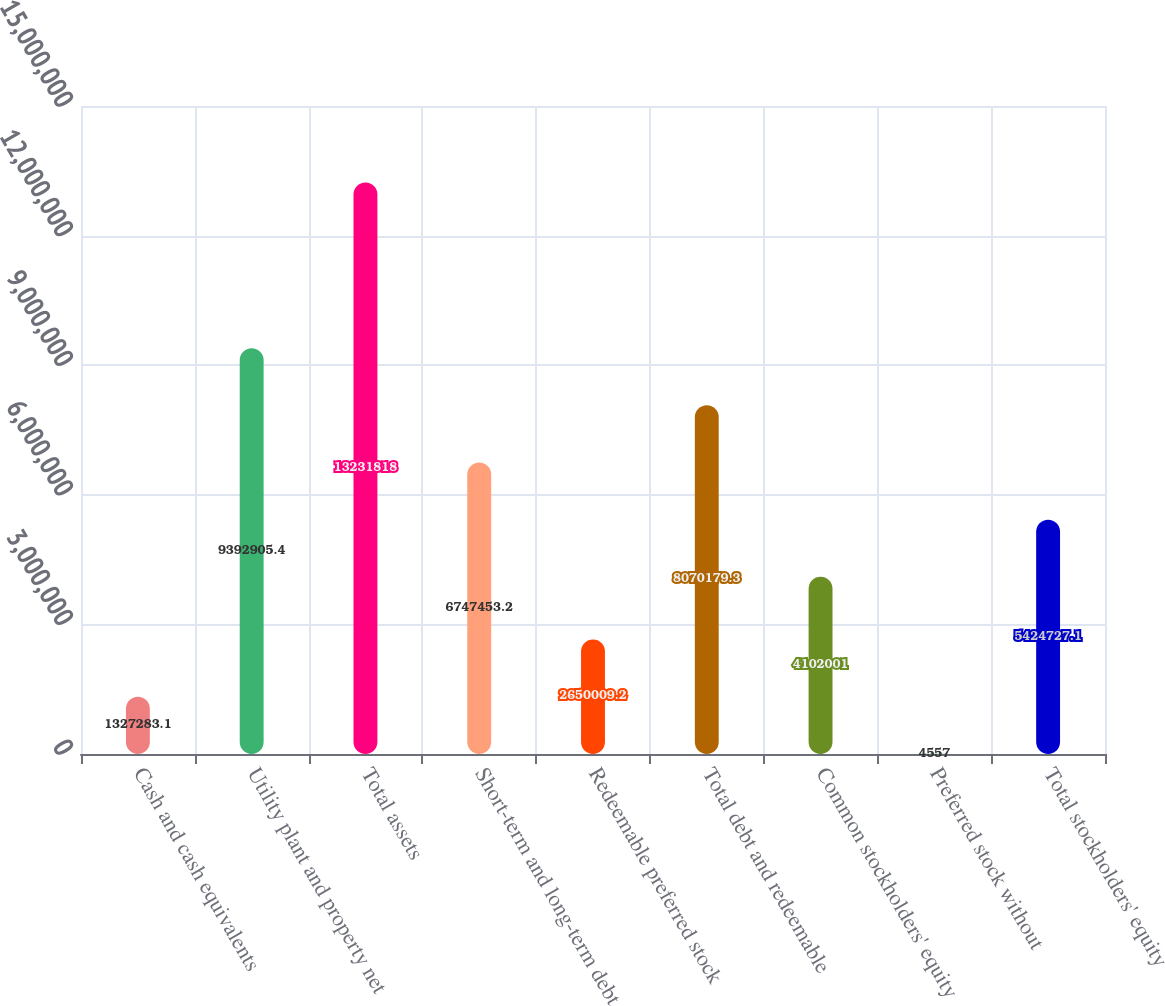<chart> <loc_0><loc_0><loc_500><loc_500><bar_chart><fcel>Cash and cash equivalents<fcel>Utility plant and property net<fcel>Total assets<fcel>Short-term and long-term debt<fcel>Redeemable preferred stock<fcel>Total debt and redeemable<fcel>Common stockholders' equity<fcel>Preferred stock without<fcel>Total stockholders' equity<nl><fcel>1.32728e+06<fcel>9.39291e+06<fcel>1.32318e+07<fcel>6.74745e+06<fcel>2.65001e+06<fcel>8.07018e+06<fcel>4.102e+06<fcel>4557<fcel>5.42473e+06<nl></chart> 